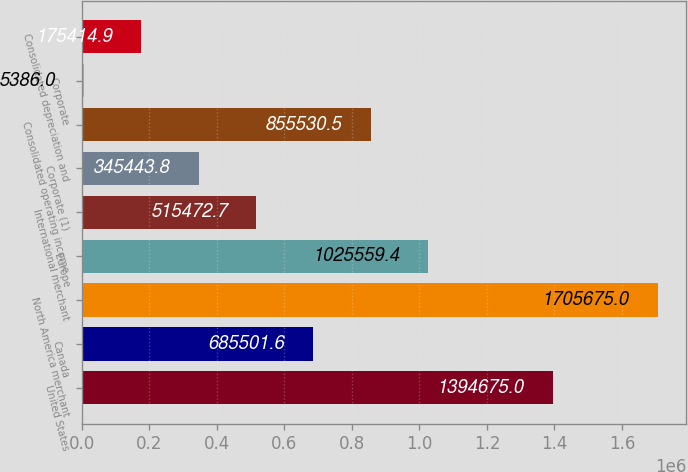Convert chart. <chart><loc_0><loc_0><loc_500><loc_500><bar_chart><fcel>United States<fcel>Canada<fcel>North America merchant<fcel>Europe<fcel>International merchant<fcel>Corporate (1)<fcel>Consolidated operating income<fcel>Corporate<fcel>Consolidated depreciation and<nl><fcel>1.39468e+06<fcel>685502<fcel>1.70568e+06<fcel>1.02556e+06<fcel>515473<fcel>345444<fcel>855530<fcel>5386<fcel>175415<nl></chart> 